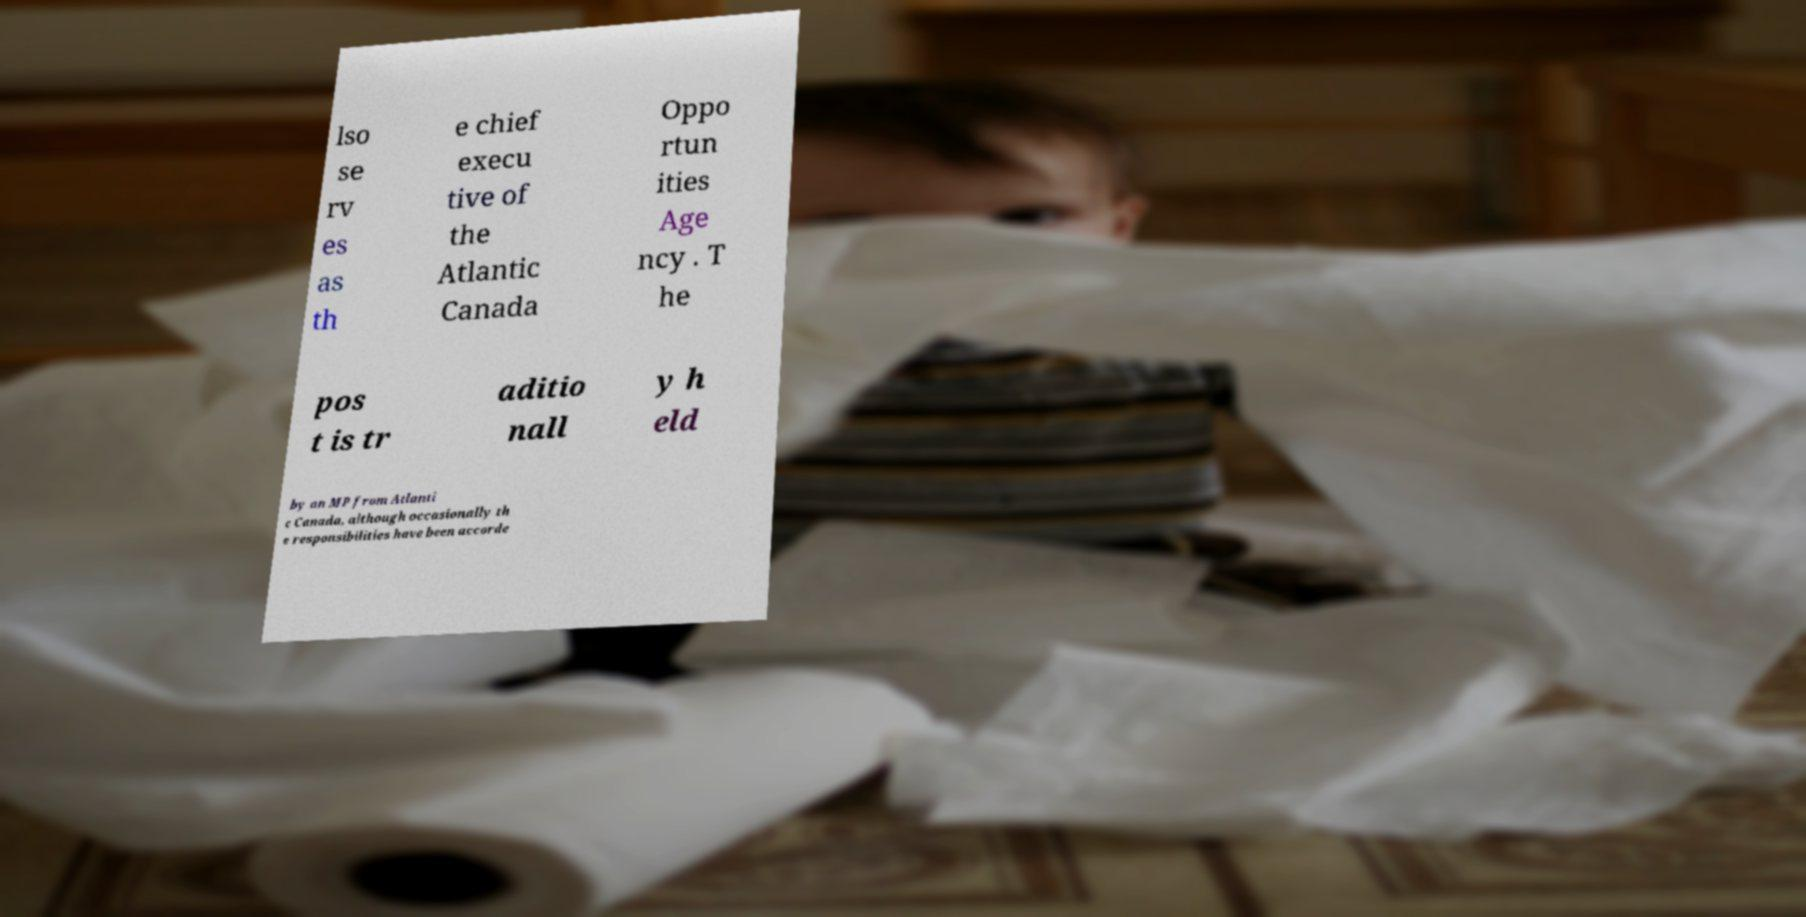Can you read and provide the text displayed in the image?This photo seems to have some interesting text. Can you extract and type it out for me? lso se rv es as th e chief execu tive of the Atlantic Canada Oppo rtun ities Age ncy . T he pos t is tr aditio nall y h eld by an MP from Atlanti c Canada, although occasionally th e responsibilities have been accorde 